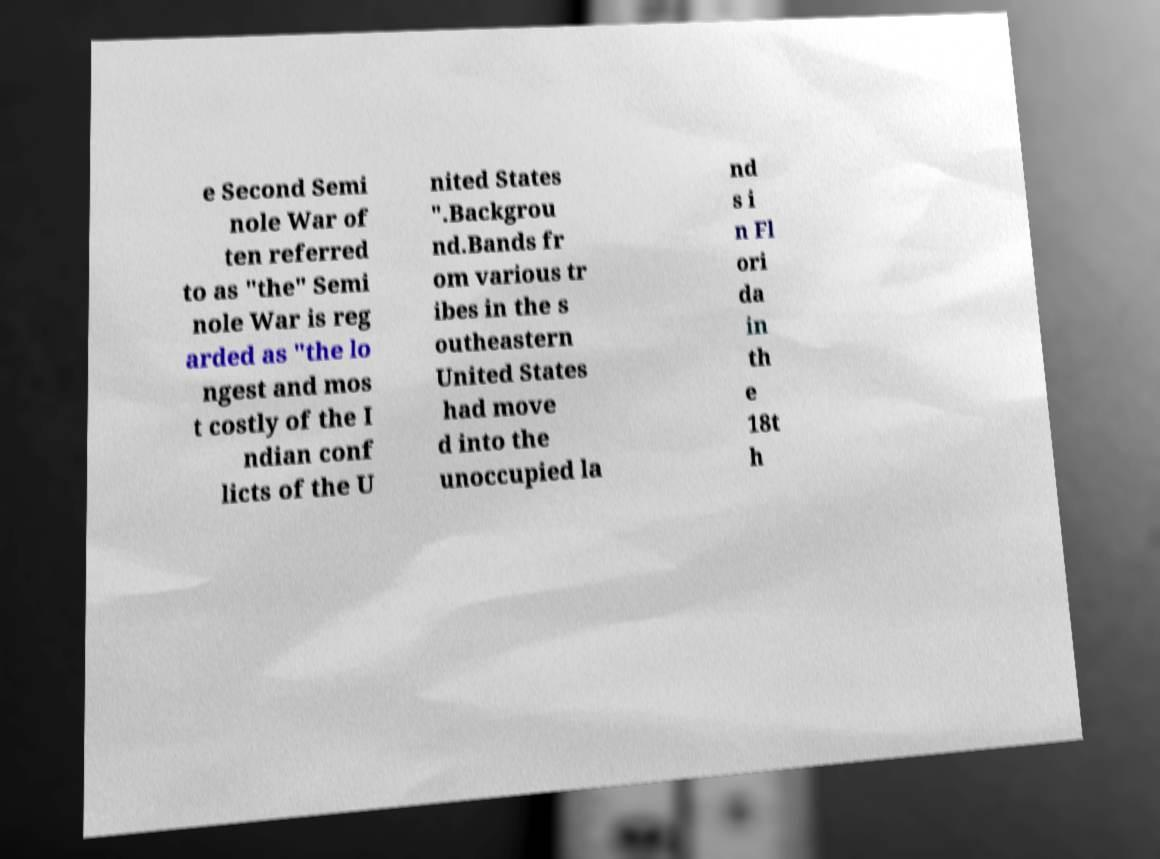I need the written content from this picture converted into text. Can you do that? e Second Semi nole War of ten referred to as "the" Semi nole War is reg arded as "the lo ngest and mos t costly of the I ndian conf licts of the U nited States ".Backgrou nd.Bands fr om various tr ibes in the s outheastern United States had move d into the unoccupied la nd s i n Fl ori da in th e 18t h 